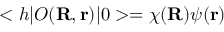Convert formula to latex. <formula><loc_0><loc_0><loc_500><loc_500>< h | O ( { R } , { r } ) | 0 > = \chi ( { R } ) \psi ( { r } )</formula> 